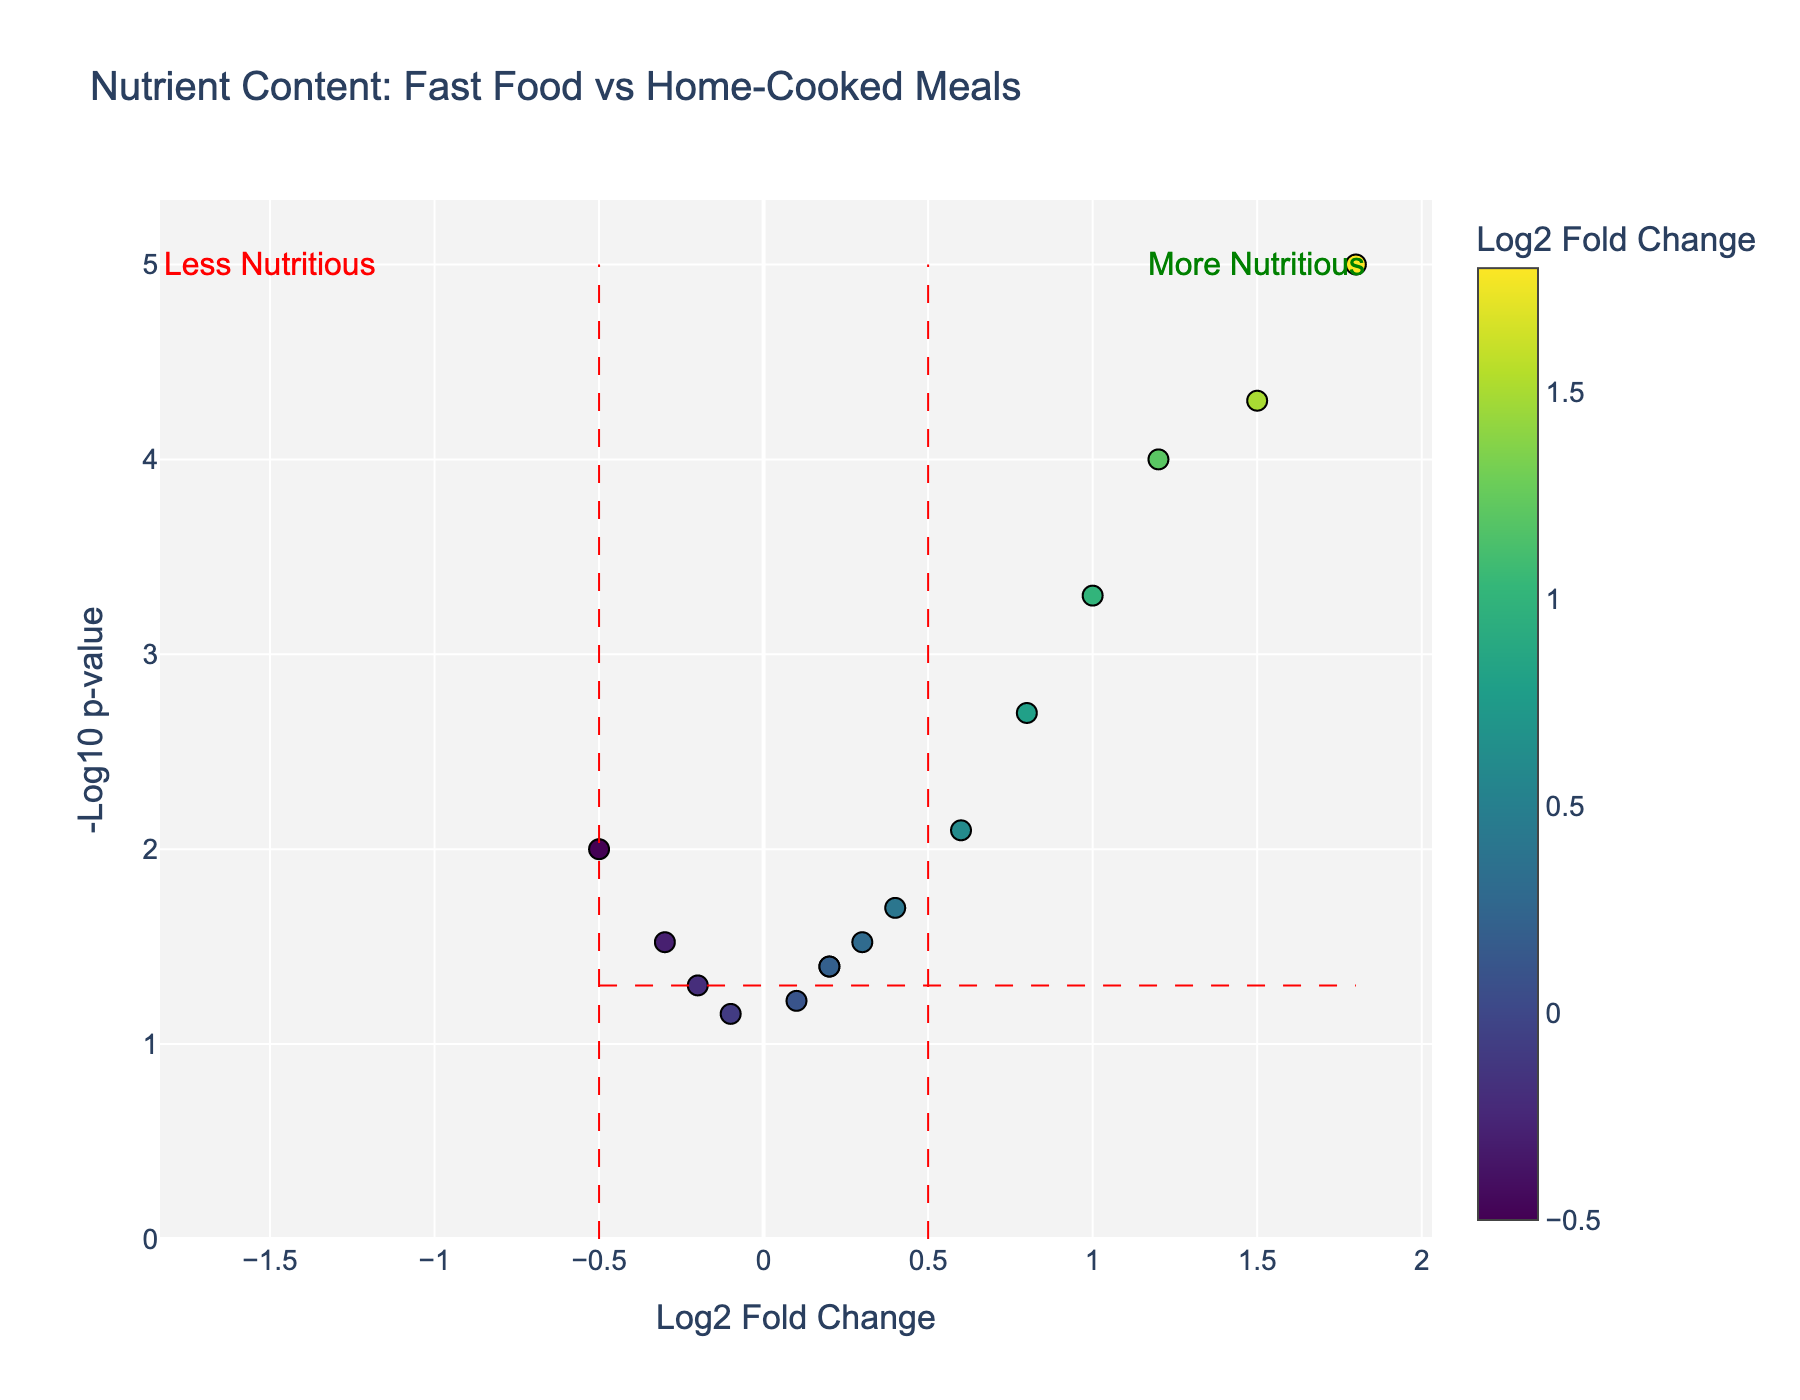What is the title of the figure? The title can usually be found at the top of the plot and is meant to provide a summary of what the figure represents. In this case, the title is "Nutrient Content: Fast Food vs Home-Cooked Meals".
Answer: Nutrient Content: Fast Food vs Home-Cooked Meals Which food item has the highest Log2 Fold Change? To find this, look at the x-axis (Log2 Fold Change) and find the point furthest to the right. Based on the data, the highest Log2 Fold Change is for the Homemade Quinoa Bowl.
Answer: Homemade Quinoa Bowl What does a high value on the x-axis (Log2 Fold Change) signify in this plot? A high value on the x-axis indicates a higher Log2 Fold Change, which suggests that the nutrient content of that food item is significantly higher compared to a baseline. Higher values mean the item is more nutritious.
Answer: More nutritious How many food items have a p-value < 0.05? To determine this, look at the y-axis (-Log10 p-value) and identify the points above the significance threshold line (-Log10(0.05)). Count them. Based on the data, 11 items meet this criterion.
Answer: 11 Which food item is indicated to be less nutritious but is still statistically significant? Look at the points on the left side of the y-axis (negative Log2 Fold Change) above the significance threshold line. The Subway Veggie Delite has the lowest Log2 Fold Change among these points.
Answer: Subway Veggie Delite How does the nutrient content of Homemade Lentil Soup compare to the Taco Bell Bean Burrito in terms of Log2 Fold Change? To compare, find the x-axis positions of both items. Homemade Lentil Soup has a higher Log2 Fold Change (1.5) compared to the Taco Bell Bean Burrito (-0.3), indicating it is more nutritious.
Answer: Homemade Lentil Soup is more nutritious What does the position of the KFC Grilled Chicken indicate in terms of statistical significance and nutrient content change? KFC Grilled Chicken is found to the left of the y-axis center (negative Log2 Fold Change) and below the p-value threshold line (-Log10(0.05)). This indicates it is slightly less nutritious and not statistically significant.
Answer: Less nutritious, not significant How does the nutrient content of Wendys Apple Pecan Salad compare to Panera Greek Salad in terms of Log2 Fold Change? Both points can be compared by their x-axis positions. Wendys Apple Pecan Salad has a Log2 Fold Change of 0.4, while Panera Greek Salad has 0.6, indicating the Panera Greek Salad is more nutritious.
Answer: Panera Greek Salad is more nutritious Explain the relevance of the colors used in the figure. The colors represent different Log2 Fold Change values, with a gradient indicating variations in nutrient content. Items with higher Log2 Fold Change values have a different color on the scale compared to those with lower values. This helps quickly identify the relative nutrition levels of the items.
Answer: Represents Log2 Fold Change Which food item shows statistically significant higher nutrient content and the highest fold change overall? This can be determined by looking at points to the right of the y-axis center and above the significance threshold. The Homemade Quinoa Bowl has the highest Log2 Fold Change (1.8) and is statistically significant.
Answer: Homemade Quinoa Bowl 